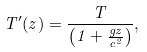Convert formula to latex. <formula><loc_0><loc_0><loc_500><loc_500>T ^ { \prime } ( z ) = \frac { T } { \left ( 1 + \frac { g z } { c ^ { 2 } } \right ) } ,</formula> 